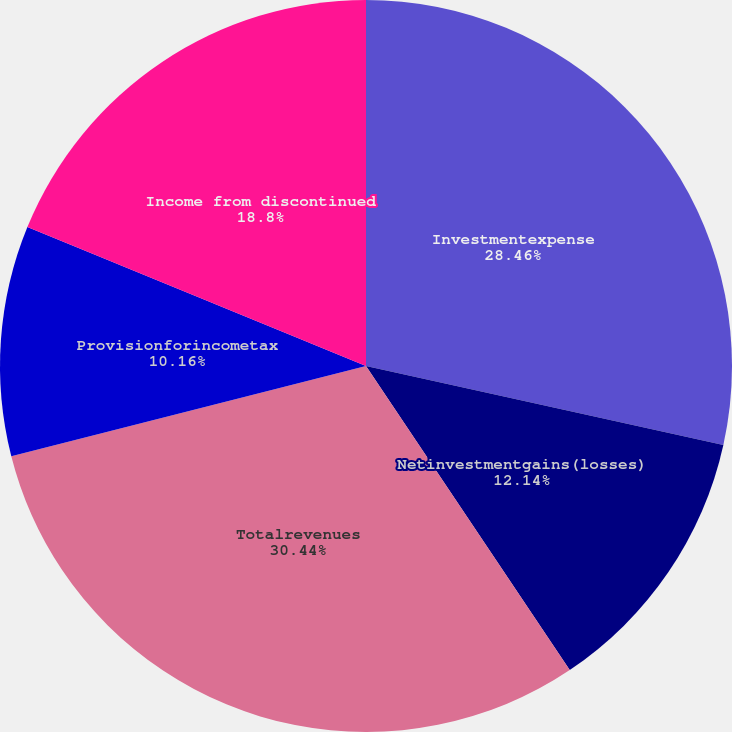Convert chart to OTSL. <chart><loc_0><loc_0><loc_500><loc_500><pie_chart><fcel>Investmentexpense<fcel>Netinvestmentgains(losses)<fcel>Totalrevenues<fcel>Provisionforincometax<fcel>Income from discontinued<nl><fcel>28.46%<fcel>12.14%<fcel>30.43%<fcel>10.16%<fcel>18.8%<nl></chart> 